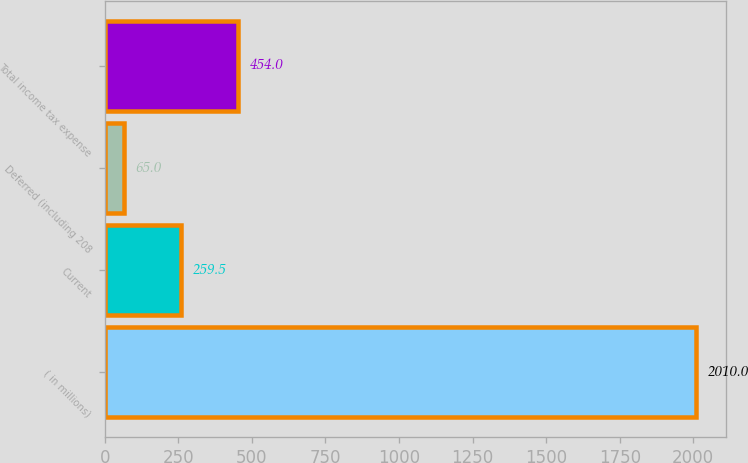Convert chart to OTSL. <chart><loc_0><loc_0><loc_500><loc_500><bar_chart><fcel>( in millions)<fcel>Current<fcel>Deferred (including 208<fcel>Total income tax expense<nl><fcel>2010<fcel>259.5<fcel>65<fcel>454<nl></chart> 